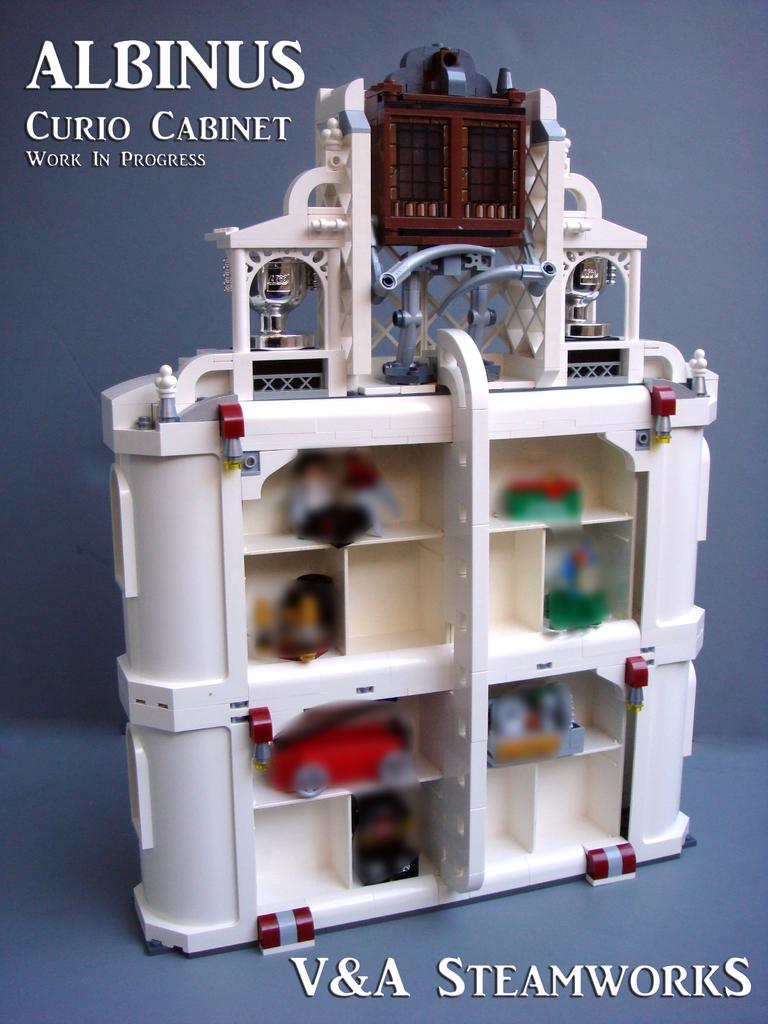<image>
Give a short and clear explanation of the subsequent image. An Albinus Curio cabinet is being advertised for V & A Steamworks. 